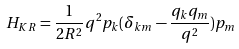Convert formula to latex. <formula><loc_0><loc_0><loc_500><loc_500>H _ { K R } = \frac { 1 } { 2 R ^ { 2 } } q ^ { 2 } p _ { k } ( \delta _ { k m } - \frac { q _ { k } q _ { m } } { q ^ { 2 } } ) p _ { m }</formula> 